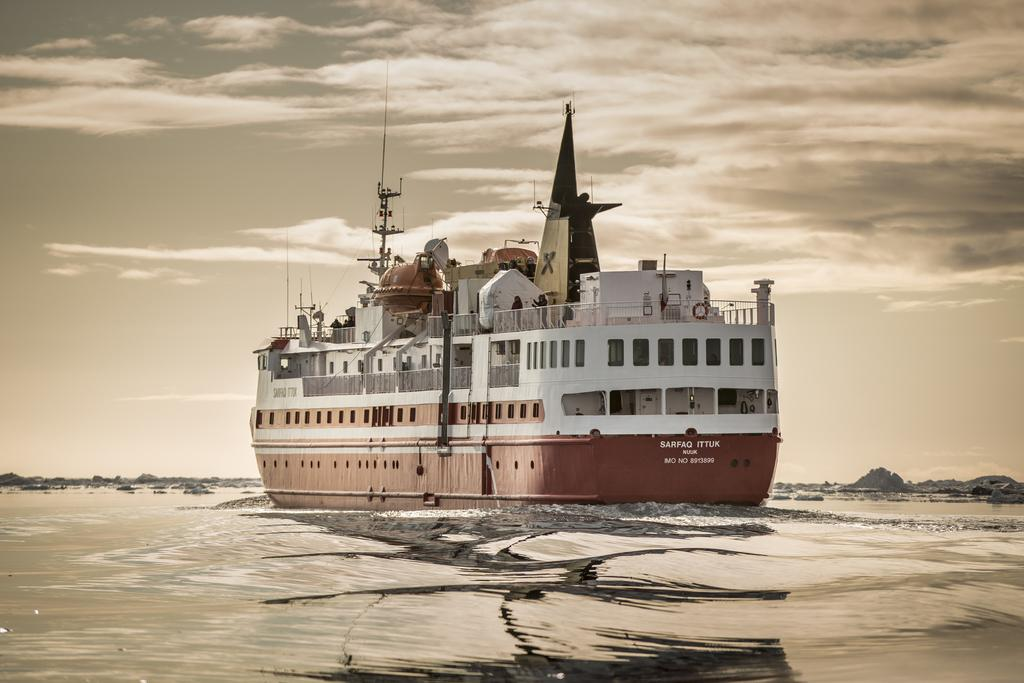What is the main subject of the image? The main subject of the image is a ship. Where is the ship located? The ship is on the water. What colors can be seen on the ship? The ship has a white and brown color. What can be seen in the background of the image? There are clouds and the sky visible in the background of the image. How many bricks are visible on the ship in the image? There are no bricks visible on the ship in the image. What type of legs can be seen on the ship in the image? Ships do not have legs; they are supported by water. 